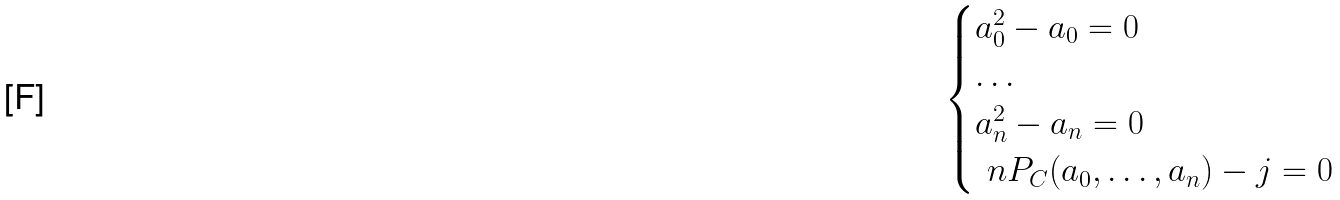<formula> <loc_0><loc_0><loc_500><loc_500>\begin{cases} a _ { 0 } ^ { 2 } - a _ { 0 } = 0 \\ \dots \\ a _ { n } ^ { 2 } - a _ { n } = 0 \\ \ n P _ { C } ( a _ { 0 } , \dots , a _ { n } ) - j = 0 \end{cases}</formula> 